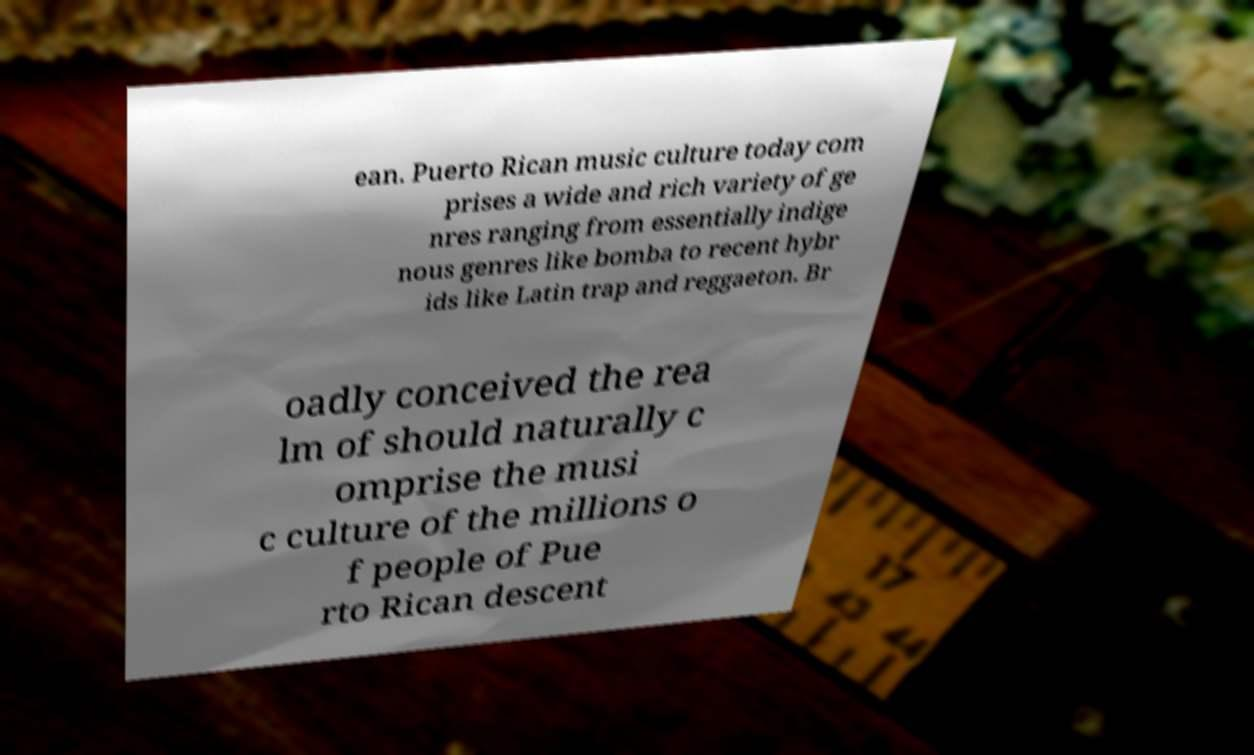Please identify and transcribe the text found in this image. ean. Puerto Rican music culture today com prises a wide and rich variety of ge nres ranging from essentially indige nous genres like bomba to recent hybr ids like Latin trap and reggaeton. Br oadly conceived the rea lm of should naturally c omprise the musi c culture of the millions o f people of Pue rto Rican descent 